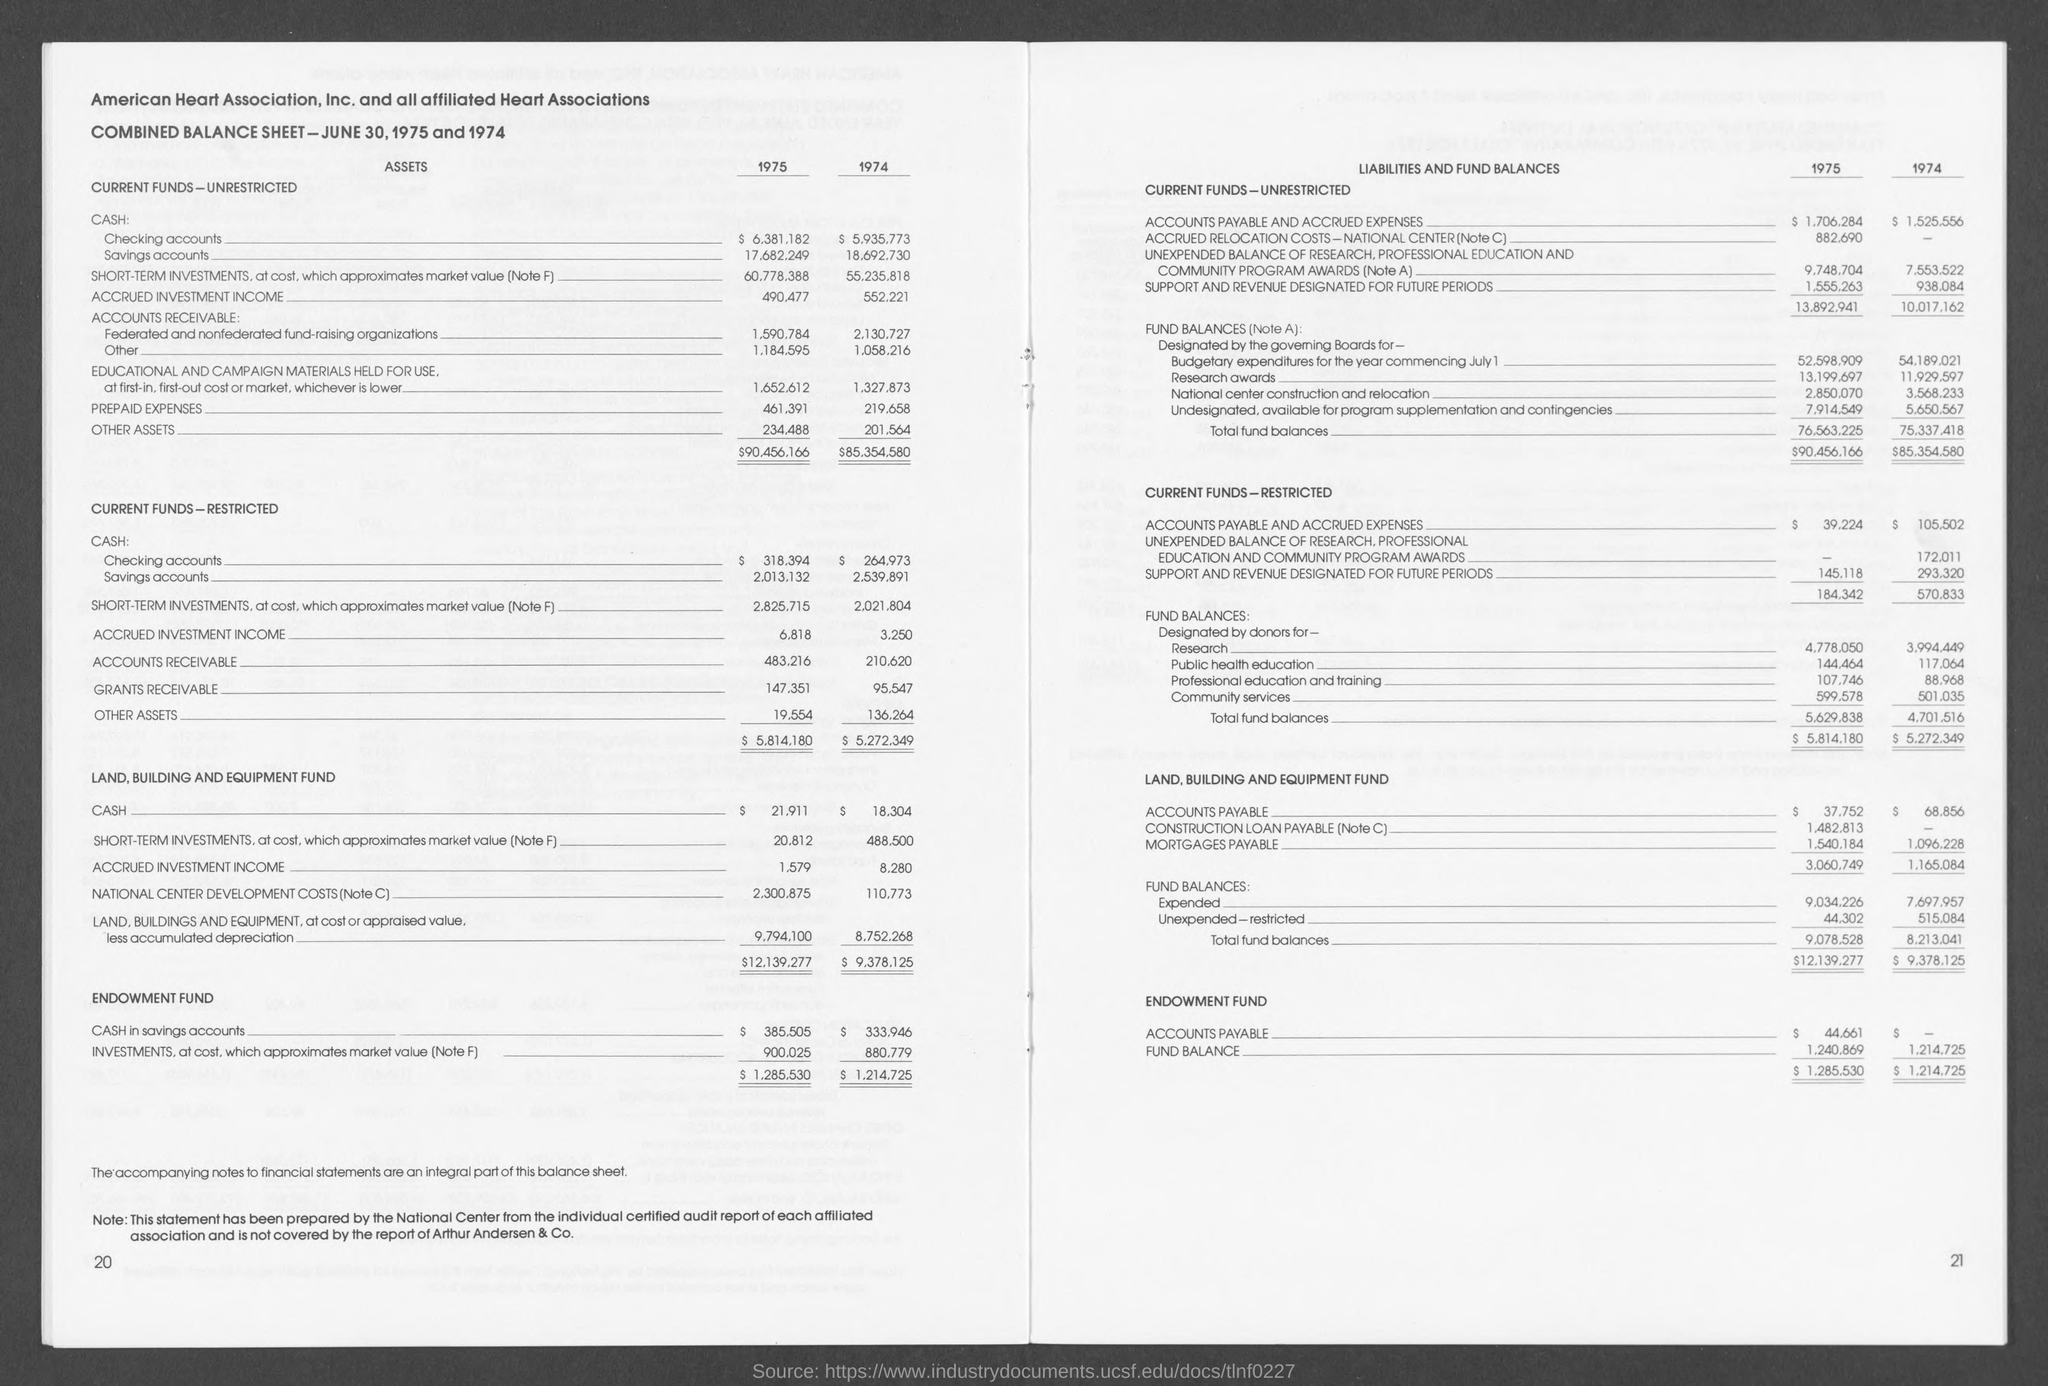What is the amount for research in fund balances in 1974  as mentioned in the given page ?
Give a very brief answer. 3,994,449. What is the amount for public health education in 1975 as mentioned in the given page ?
Provide a succinct answer. 144,464. 